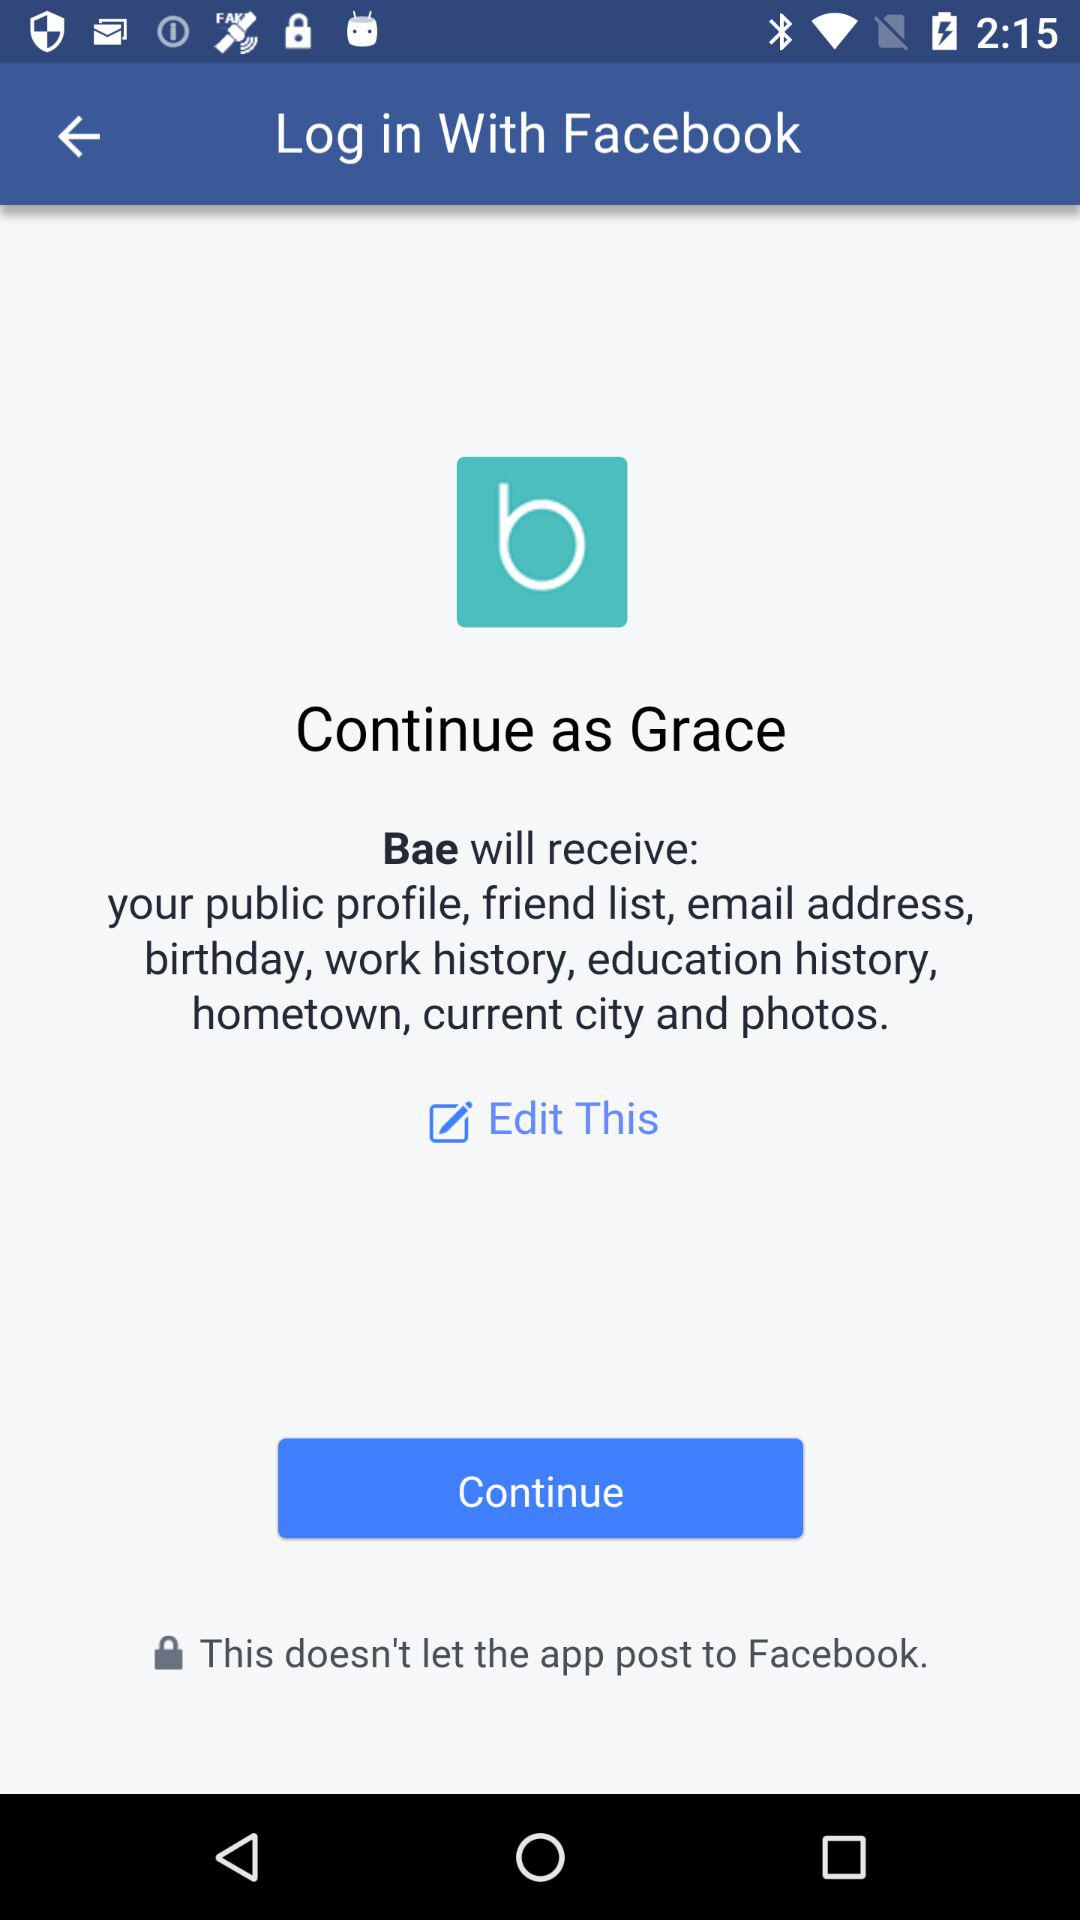What application is asking for permission? The application "Bae" is asking for permission. 